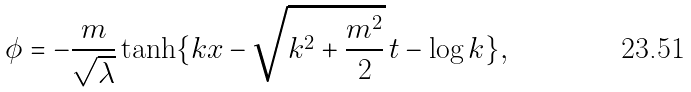Convert formula to latex. <formula><loc_0><loc_0><loc_500><loc_500>\phi = - \frac { m } { \sqrt { \lambda } } \tanh \{ k x - \sqrt { k ^ { 2 } + \frac { m ^ { 2 } } { 2 } } \, t - \log k \} ,</formula> 